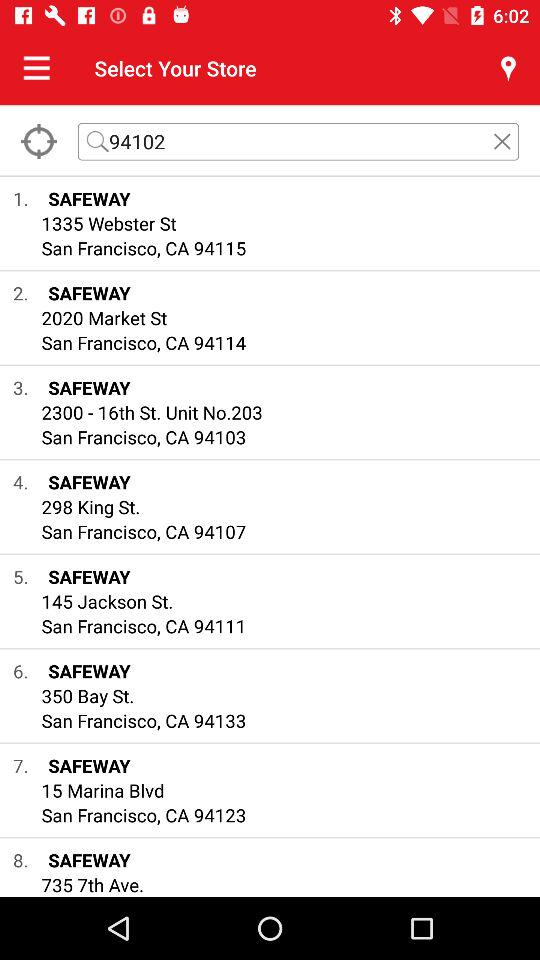What are the locations of the Safeway stores in San Francisco? The Safeway store locations are: "SAFEWAY 1335 Webster St San Francisco, CA 94115", "SAFEWAY 2020 Market St San Francisco, CA 94114", "SAFEWAY 2300 - 16th St. Unit No.203 San Francisco, CA 94103", "SAFEWAY 298 King St. San Francisco, CA 94107", "SAFEWAY 145 Jackson St. San Francisco, CA 94111", "SAFEWAY 350 Bay St. San Francisco, CA 94133", and "SAFEWAY 15 Marina Blvd San Francisco, CA 94123". 